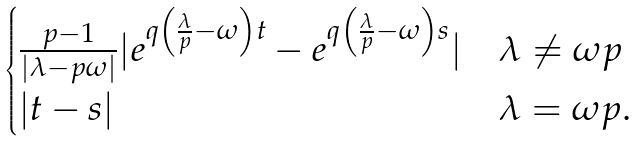<formula> <loc_0><loc_0><loc_500><loc_500>\begin{cases} \frac { p - 1 } { | \lambda - p \omega | } | e ^ { q \left ( \frac { \lambda } { p } - \omega \right ) t } - e ^ { q \left ( \frac { \lambda } { p } - \omega \right ) s } | & \lambda \not = \omega p \\ | t - s | & \lambda = \omega p . \end{cases}</formula> 